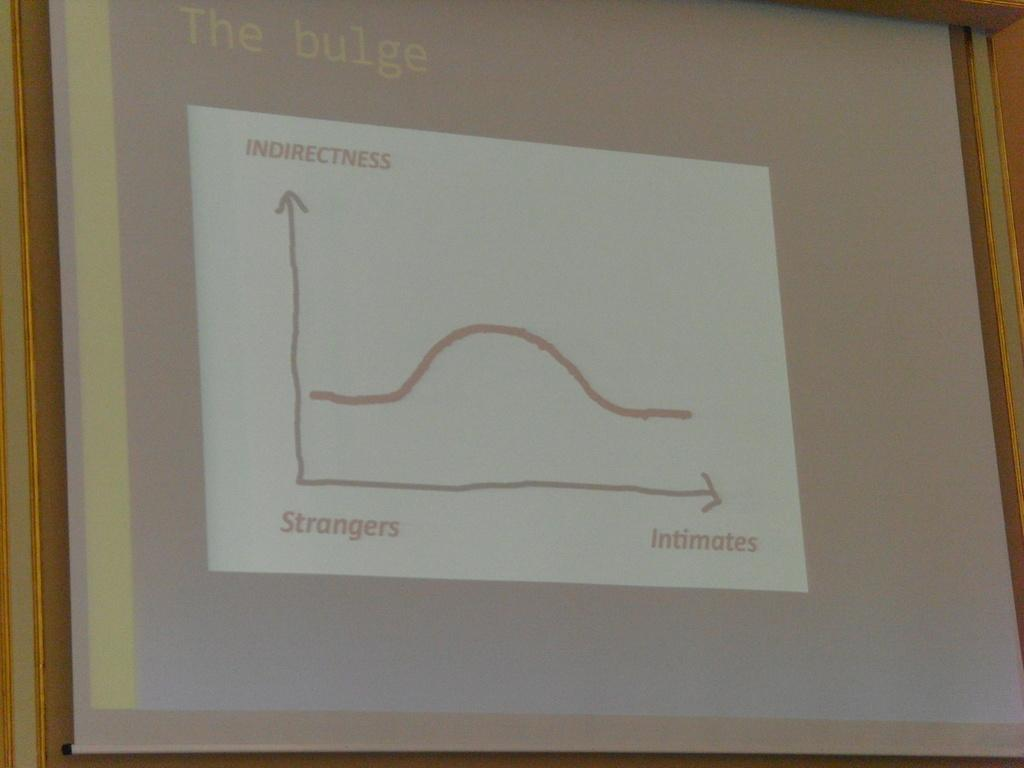<image>
Relay a brief, clear account of the picture shown. a graph with the words strangers and intimates on it 